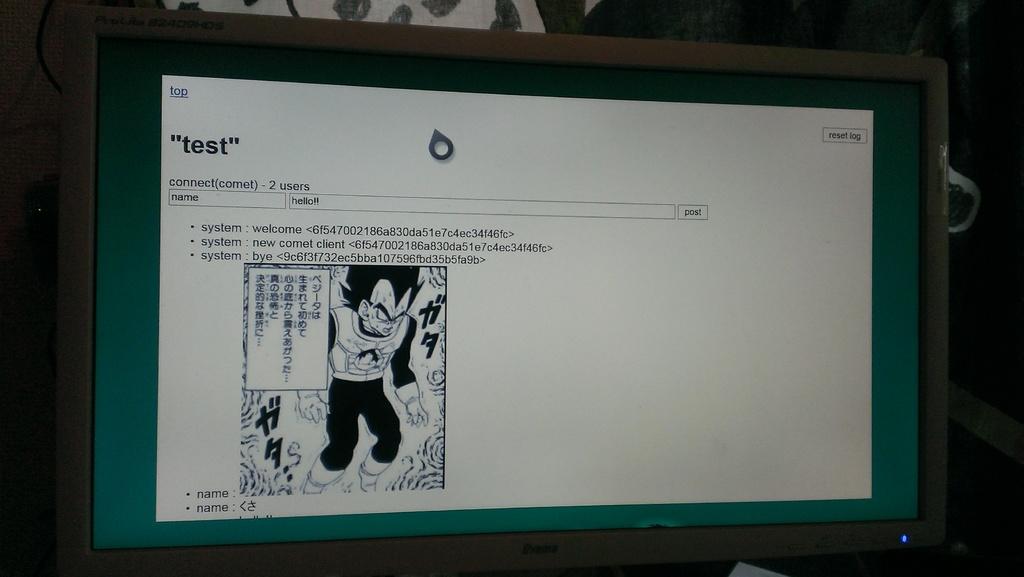Does the word test have parentheses around it at the top?
Provide a short and direct response. No. 